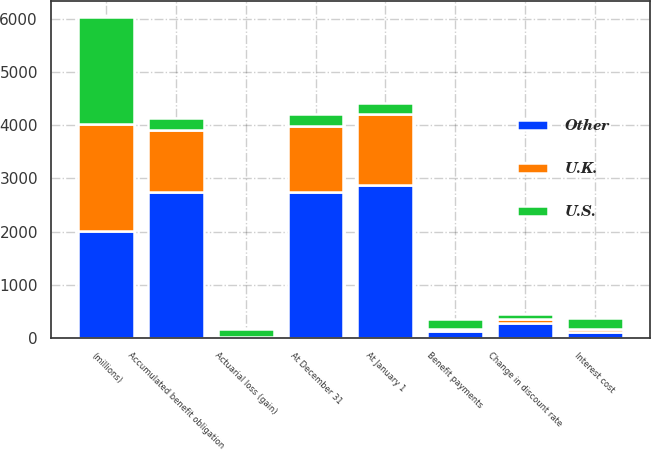<chart> <loc_0><loc_0><loc_500><loc_500><stacked_bar_chart><ecel><fcel>(millions)<fcel>At January 1<fcel>Interest cost<fcel>Actuarial loss (gain)<fcel>Benefit payments<fcel>Change in discount rate<fcel>At December 31<fcel>Accumulated benefit obligation<nl><fcel>U.S.<fcel>2013<fcel>210<fcel>210<fcel>145<fcel>186<fcel>95<fcel>210<fcel>210<nl><fcel>Other<fcel>2013<fcel>2884<fcel>114<fcel>17<fcel>128<fcel>277<fcel>2744<fcel>2744<nl><fcel>U.K.<fcel>2013<fcel>1323<fcel>45<fcel>1<fcel>44<fcel>85<fcel>1252<fcel>1177<nl></chart> 